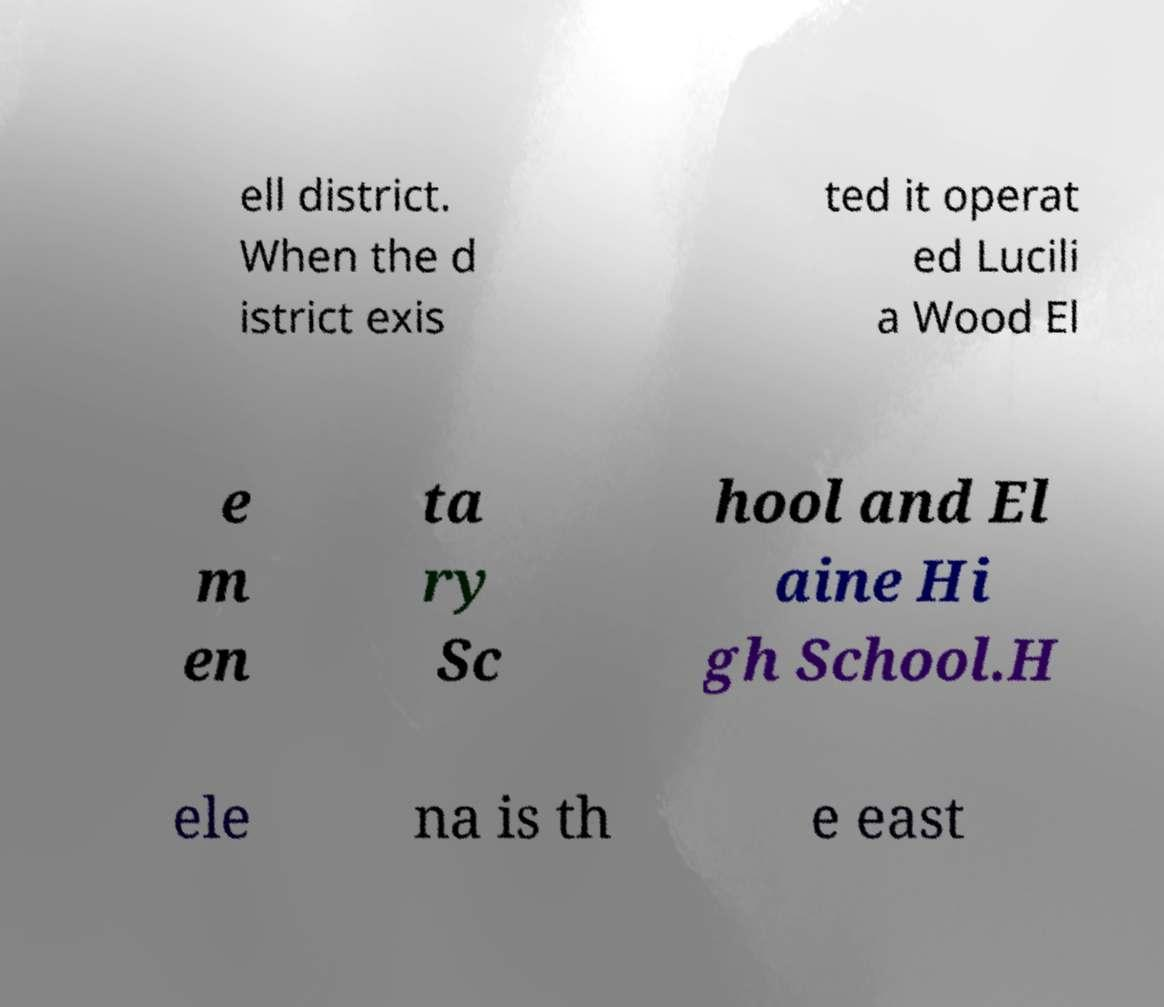There's text embedded in this image that I need extracted. Can you transcribe it verbatim? ell district. When the d istrict exis ted it operat ed Lucili a Wood El e m en ta ry Sc hool and El aine Hi gh School.H ele na is th e east 